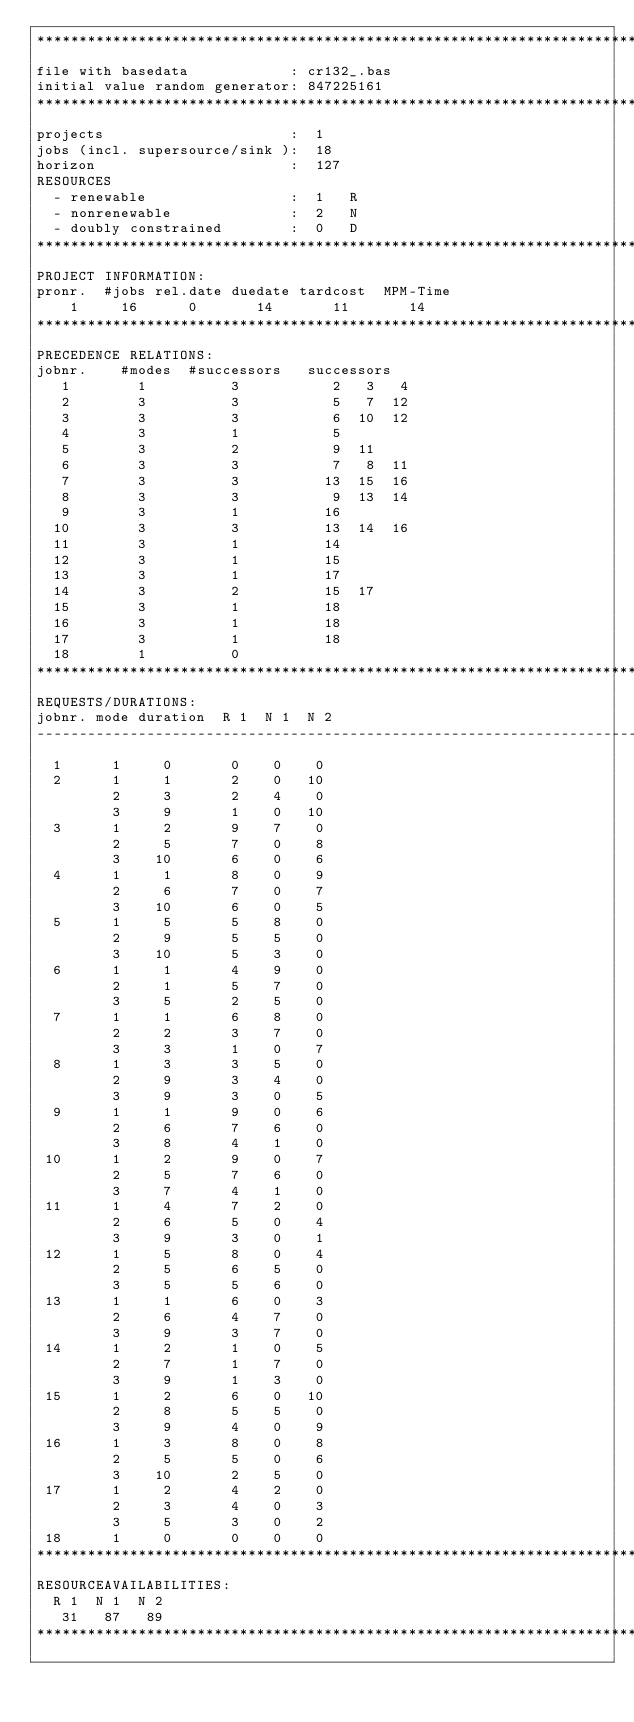Convert code to text. <code><loc_0><loc_0><loc_500><loc_500><_ObjectiveC_>************************************************************************
file with basedata            : cr132_.bas
initial value random generator: 847225161
************************************************************************
projects                      :  1
jobs (incl. supersource/sink ):  18
horizon                       :  127
RESOURCES
  - renewable                 :  1   R
  - nonrenewable              :  2   N
  - doubly constrained        :  0   D
************************************************************************
PROJECT INFORMATION:
pronr.  #jobs rel.date duedate tardcost  MPM-Time
    1     16      0       14       11       14
************************************************************************
PRECEDENCE RELATIONS:
jobnr.    #modes  #successors   successors
   1        1          3           2   3   4
   2        3          3           5   7  12
   3        3          3           6  10  12
   4        3          1           5
   5        3          2           9  11
   6        3          3           7   8  11
   7        3          3          13  15  16
   8        3          3           9  13  14
   9        3          1          16
  10        3          3          13  14  16
  11        3          1          14
  12        3          1          15
  13        3          1          17
  14        3          2          15  17
  15        3          1          18
  16        3          1          18
  17        3          1          18
  18        1          0        
************************************************************************
REQUESTS/DURATIONS:
jobnr. mode duration  R 1  N 1  N 2
------------------------------------------------------------------------
  1      1     0       0    0    0
  2      1     1       2    0   10
         2     3       2    4    0
         3     9       1    0   10
  3      1     2       9    7    0
         2     5       7    0    8
         3    10       6    0    6
  4      1     1       8    0    9
         2     6       7    0    7
         3    10       6    0    5
  5      1     5       5    8    0
         2     9       5    5    0
         3    10       5    3    0
  6      1     1       4    9    0
         2     1       5    7    0
         3     5       2    5    0
  7      1     1       6    8    0
         2     2       3    7    0
         3     3       1    0    7
  8      1     3       3    5    0
         2     9       3    4    0
         3     9       3    0    5
  9      1     1       9    0    6
         2     6       7    6    0
         3     8       4    1    0
 10      1     2       9    0    7
         2     5       7    6    0
         3     7       4    1    0
 11      1     4       7    2    0
         2     6       5    0    4
         3     9       3    0    1
 12      1     5       8    0    4
         2     5       6    5    0
         3     5       5    6    0
 13      1     1       6    0    3
         2     6       4    7    0
         3     9       3    7    0
 14      1     2       1    0    5
         2     7       1    7    0
         3     9       1    3    0
 15      1     2       6    0   10
         2     8       5    5    0
         3     9       4    0    9
 16      1     3       8    0    8
         2     5       5    0    6
         3    10       2    5    0
 17      1     2       4    2    0
         2     3       4    0    3
         3     5       3    0    2
 18      1     0       0    0    0
************************************************************************
RESOURCEAVAILABILITIES:
  R 1  N 1  N 2
   31   87   89
************************************************************************
</code> 